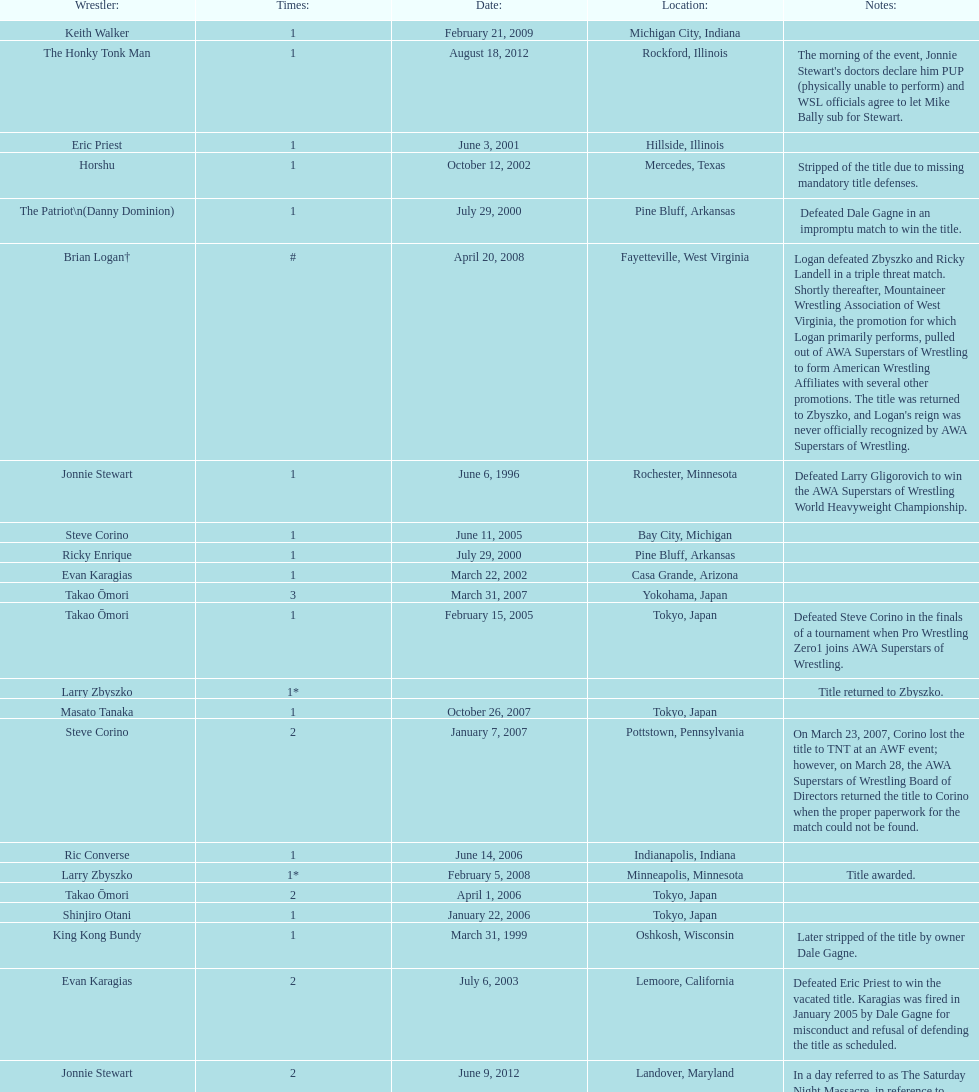How many different men held the wsl title before horshu won his first wsl title? 6. 